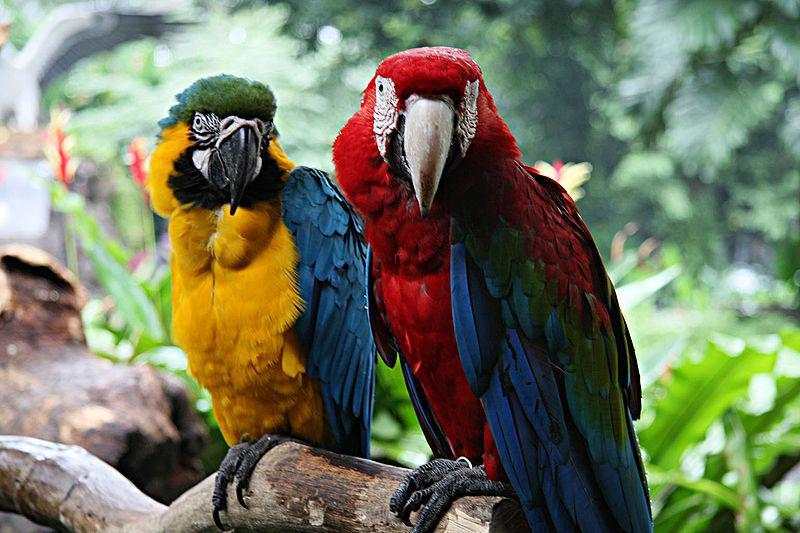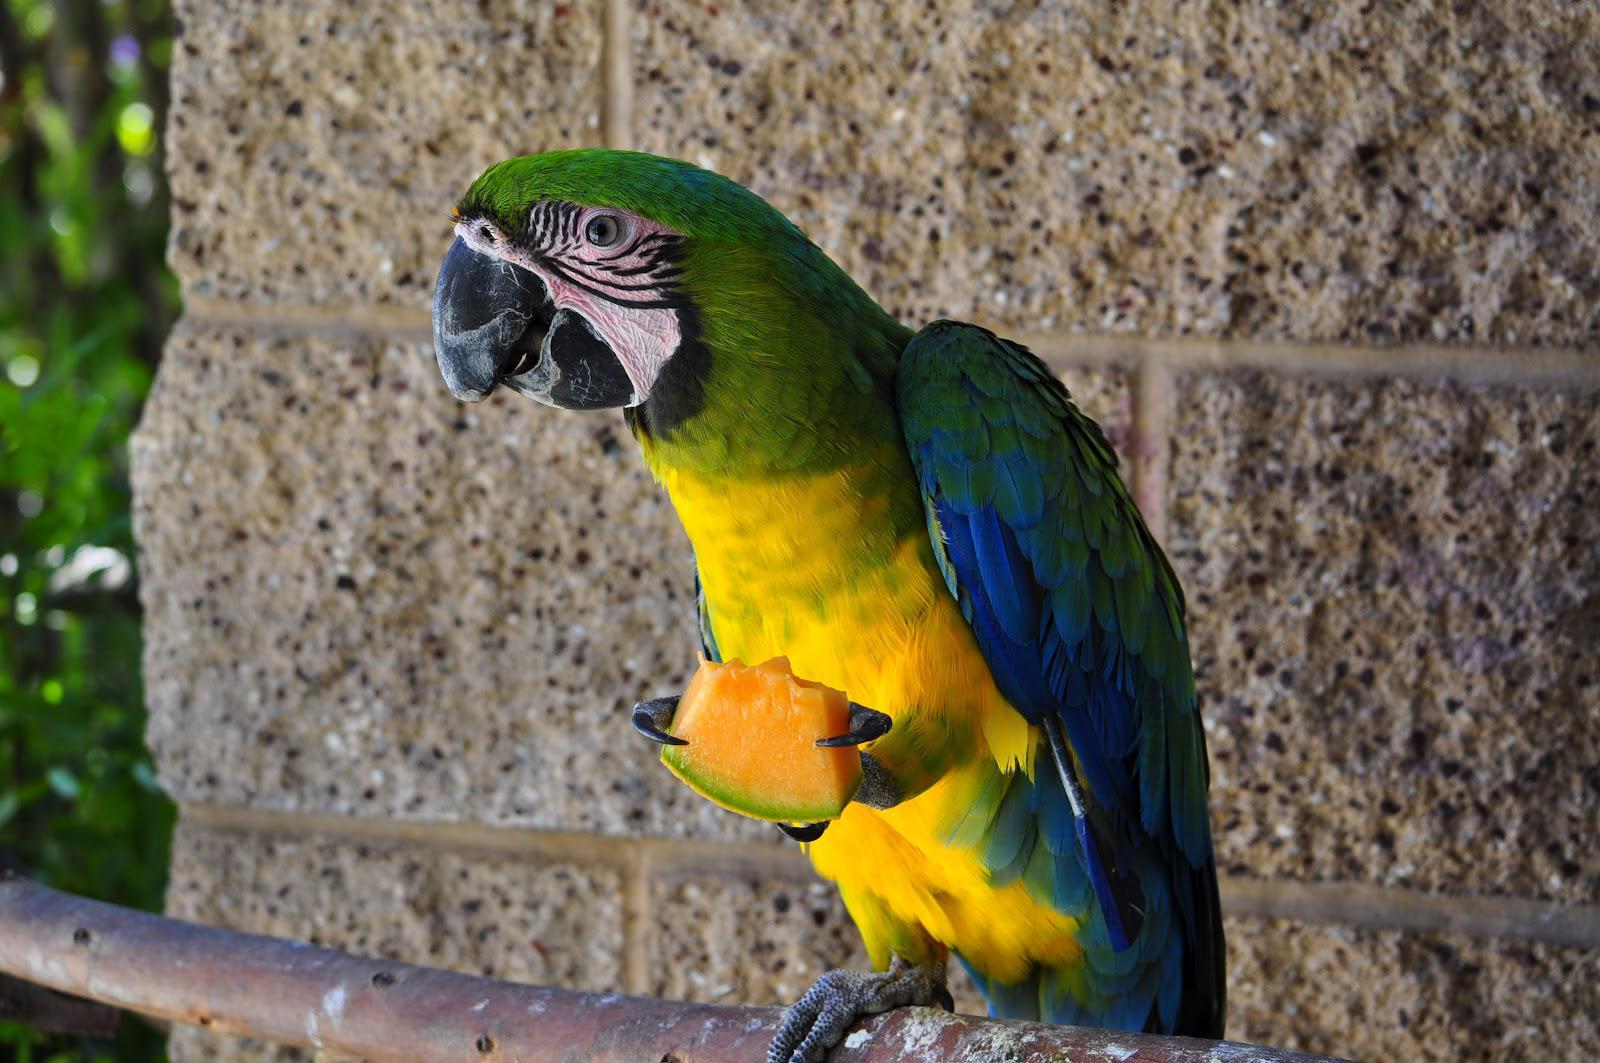The first image is the image on the left, the second image is the image on the right. Examine the images to the left and right. Is the description "There are exactly three parrots in the right image standing on a branch." accurate? Answer yes or no. No. The first image is the image on the left, the second image is the image on the right. Analyze the images presented: Is the assertion "One bird has its wings spread open." valid? Answer yes or no. No. 